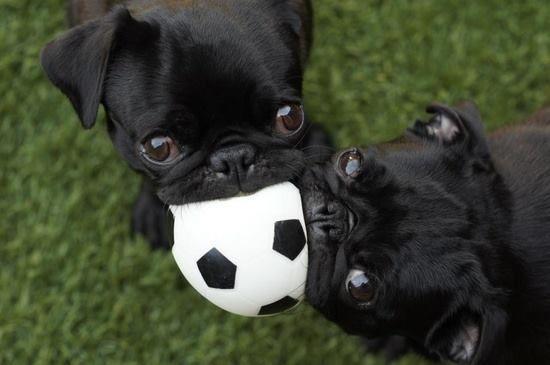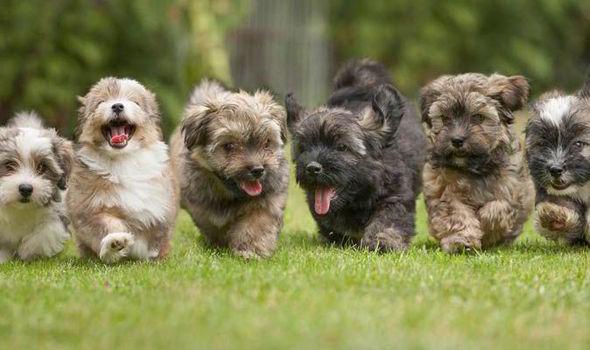The first image is the image on the left, the second image is the image on the right. Assess this claim about the two images: "There are two dogs in the image on the left.". Correct or not? Answer yes or no. Yes. 